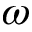Convert formula to latex. <formula><loc_0><loc_0><loc_500><loc_500>\omega</formula> 